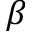Convert formula to latex. <formula><loc_0><loc_0><loc_500><loc_500>\beta</formula> 